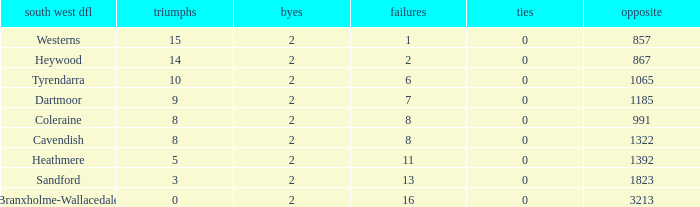How many wins have 16 losses and an Against smaller than 3213? None. 